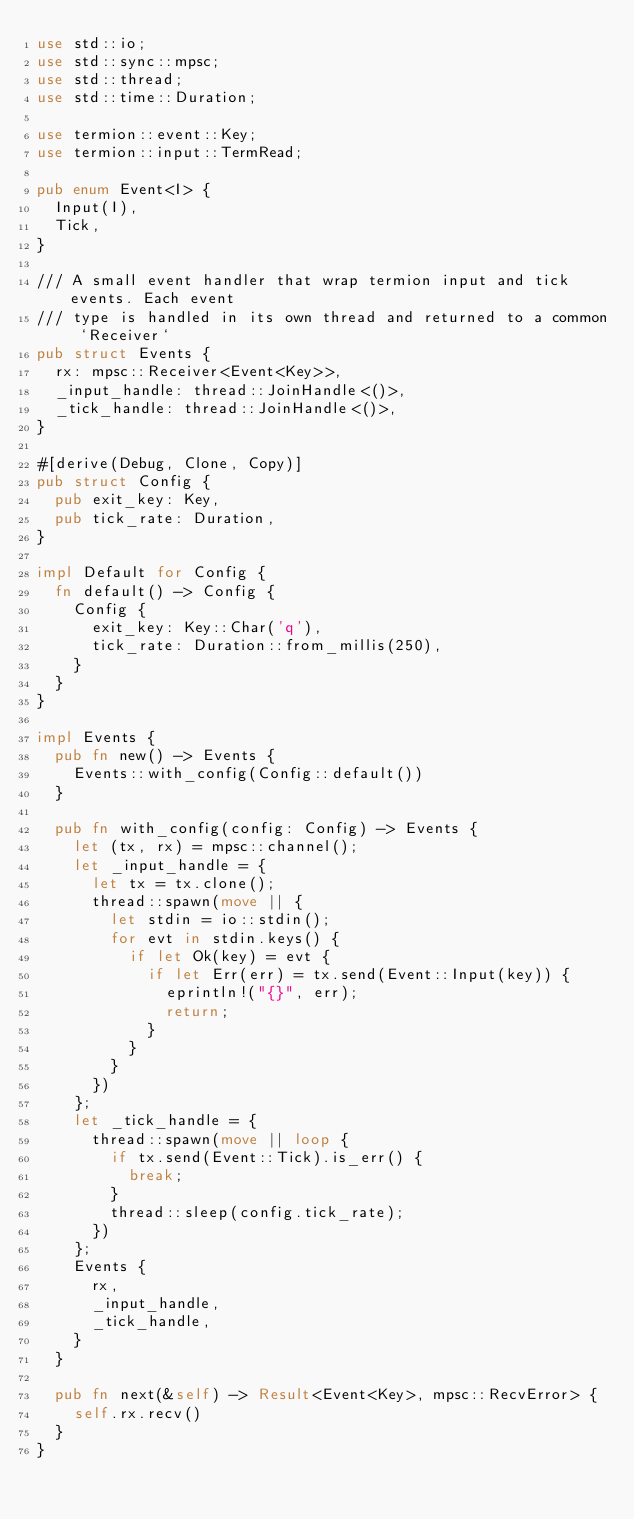<code> <loc_0><loc_0><loc_500><loc_500><_Rust_>use std::io;
use std::sync::mpsc;
use std::thread;
use std::time::Duration;

use termion::event::Key;
use termion::input::TermRead;

pub enum Event<I> {
  Input(I),
  Tick,
}

/// A small event handler that wrap termion input and tick events. Each event
/// type is handled in its own thread and returned to a common `Receiver`
pub struct Events {
  rx: mpsc::Receiver<Event<Key>>,
  _input_handle: thread::JoinHandle<()>,
  _tick_handle: thread::JoinHandle<()>,
}

#[derive(Debug, Clone, Copy)]
pub struct Config {
  pub exit_key: Key,
  pub tick_rate: Duration,
}

impl Default for Config {
  fn default() -> Config {
    Config {
      exit_key: Key::Char('q'),
      tick_rate: Duration::from_millis(250),
    }
  }
}

impl Events {
  pub fn new() -> Events {
    Events::with_config(Config::default())
  }

  pub fn with_config(config: Config) -> Events {
    let (tx, rx) = mpsc::channel();
    let _input_handle = {
      let tx = tx.clone();
      thread::spawn(move || {
        let stdin = io::stdin();
        for evt in stdin.keys() {
          if let Ok(key) = evt {
            if let Err(err) = tx.send(Event::Input(key)) {
              eprintln!("{}", err);
              return;
            }
          }
        }
      })
    };
    let _tick_handle = {
      thread::spawn(move || loop {
        if tx.send(Event::Tick).is_err() {
          break;
        }
        thread::sleep(config.tick_rate);
      })
    };
    Events {
      rx,
      _input_handle,
      _tick_handle,
    }
  }

  pub fn next(&self) -> Result<Event<Key>, mpsc::RecvError> {
    self.rx.recv()
  }
}
</code> 